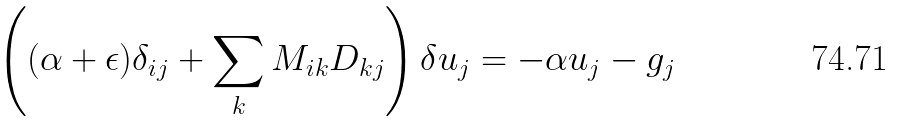Convert formula to latex. <formula><loc_0><loc_0><loc_500><loc_500>\left ( ( \alpha + \epsilon ) \delta _ { i j } + \sum _ { k } M _ { i k } D _ { k j } \right ) \delta u _ { j } = - \alpha u _ { j } - g _ { j }</formula> 